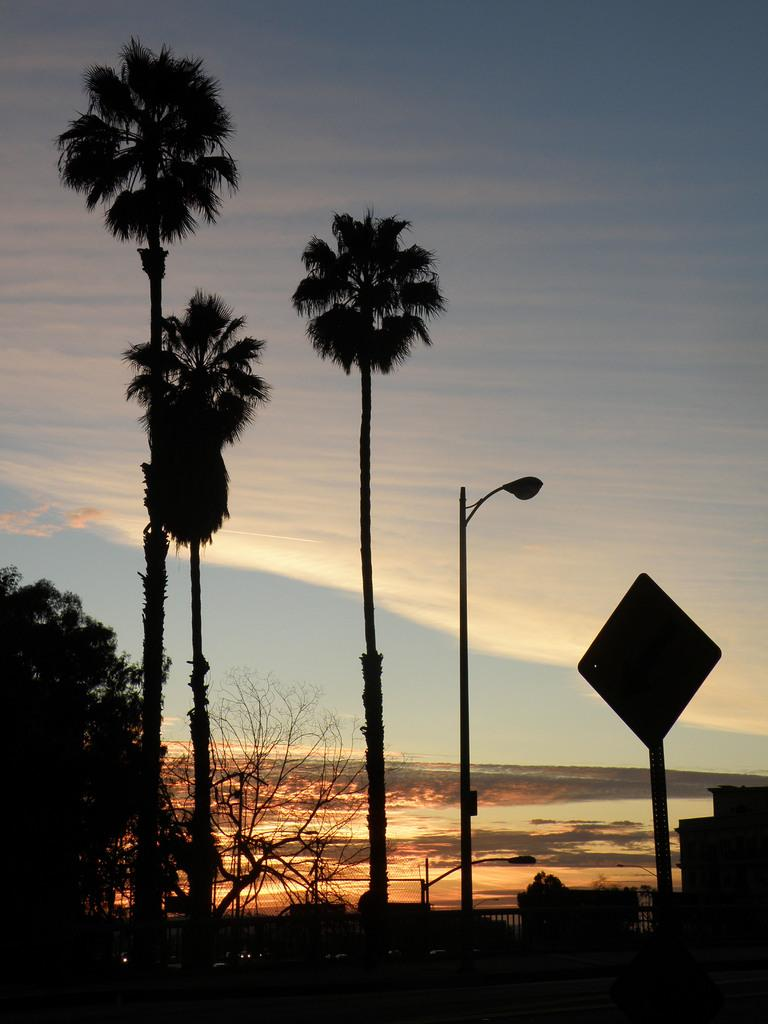What type of vegetation can be seen in the image? There are trees in the image. What structure is present near the trees? There is a light pole in the image. What type of information might be displayed on the sign board in the image? The sign board in the image might display information about directions, advertisements, or notices. What type of transportation can be seen in the image? There are vehicles in the image. What type of surface are the vehicles traveling on? There is a road in the image. What type of building is visible in the image? There is a building in the image. What can be seen in the background of the image? There are clouds and the sky visible in the background of the image. How many chickens are crossing the road in the image? There are no chickens present in the image. What type of weather can be seen in the image? The provided facts do not mention any specific weather conditions, so we cannot determine the weather from the image. 